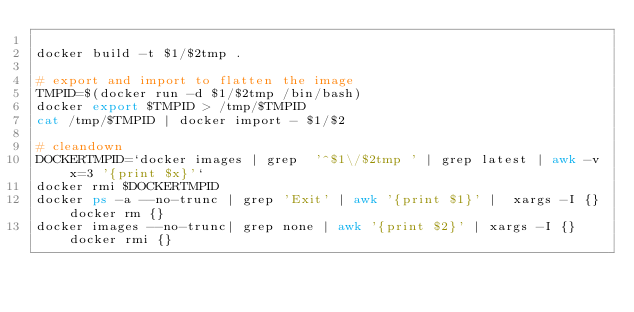Convert code to text. <code><loc_0><loc_0><loc_500><loc_500><_Bash_>
docker build -t $1/$2tmp .

# export and import to flatten the image
TMPID=$(docker run -d $1/$2tmp /bin/bash)
docker export $TMPID > /tmp/$TMPID
cat /tmp/$TMPID | docker import - $1/$2

# cleandown
DOCKERTMPID=`docker images | grep  '^$1\/$2tmp ' | grep latest | awk -v x=3 '{print $x}'`
docker rmi $DOCKERTMPID
docker ps -a --no-trunc | grep 'Exit' | awk '{print $1}' |  xargs -I {} docker rm {}
docker images --no-trunc| grep none | awk '{print $2}' | xargs -I {} docker rmi {}
</code> 